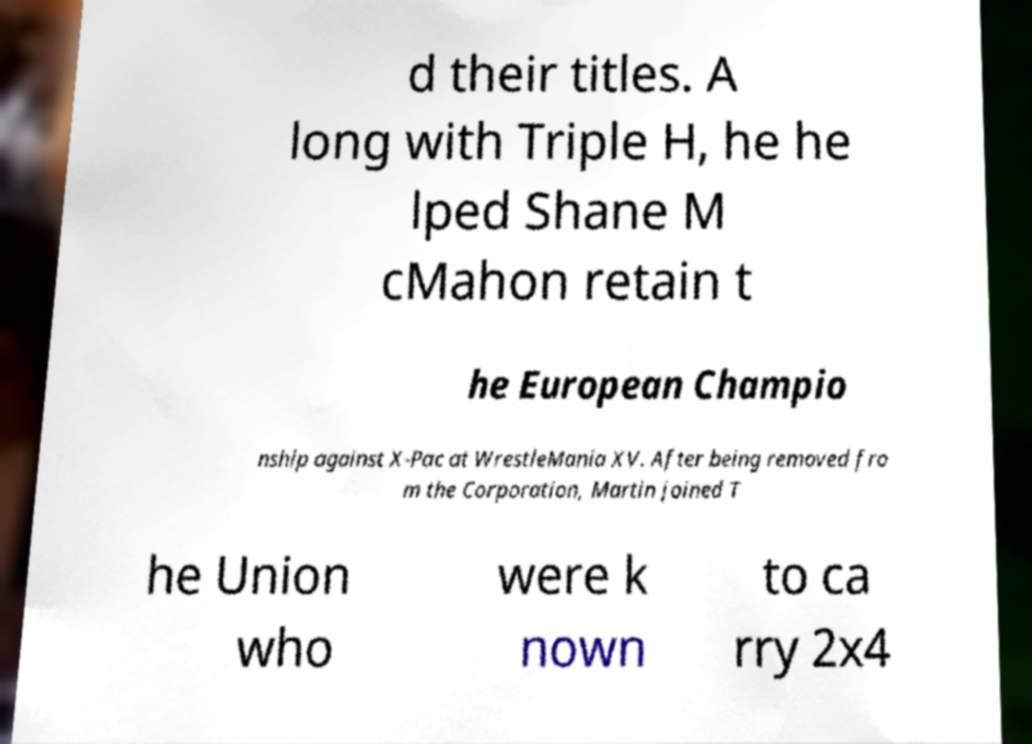Please read and relay the text visible in this image. What does it say? d their titles. A long with Triple H, he he lped Shane M cMahon retain t he European Champio nship against X-Pac at WrestleMania XV. After being removed fro m the Corporation, Martin joined T he Union who were k nown to ca rry 2x4 